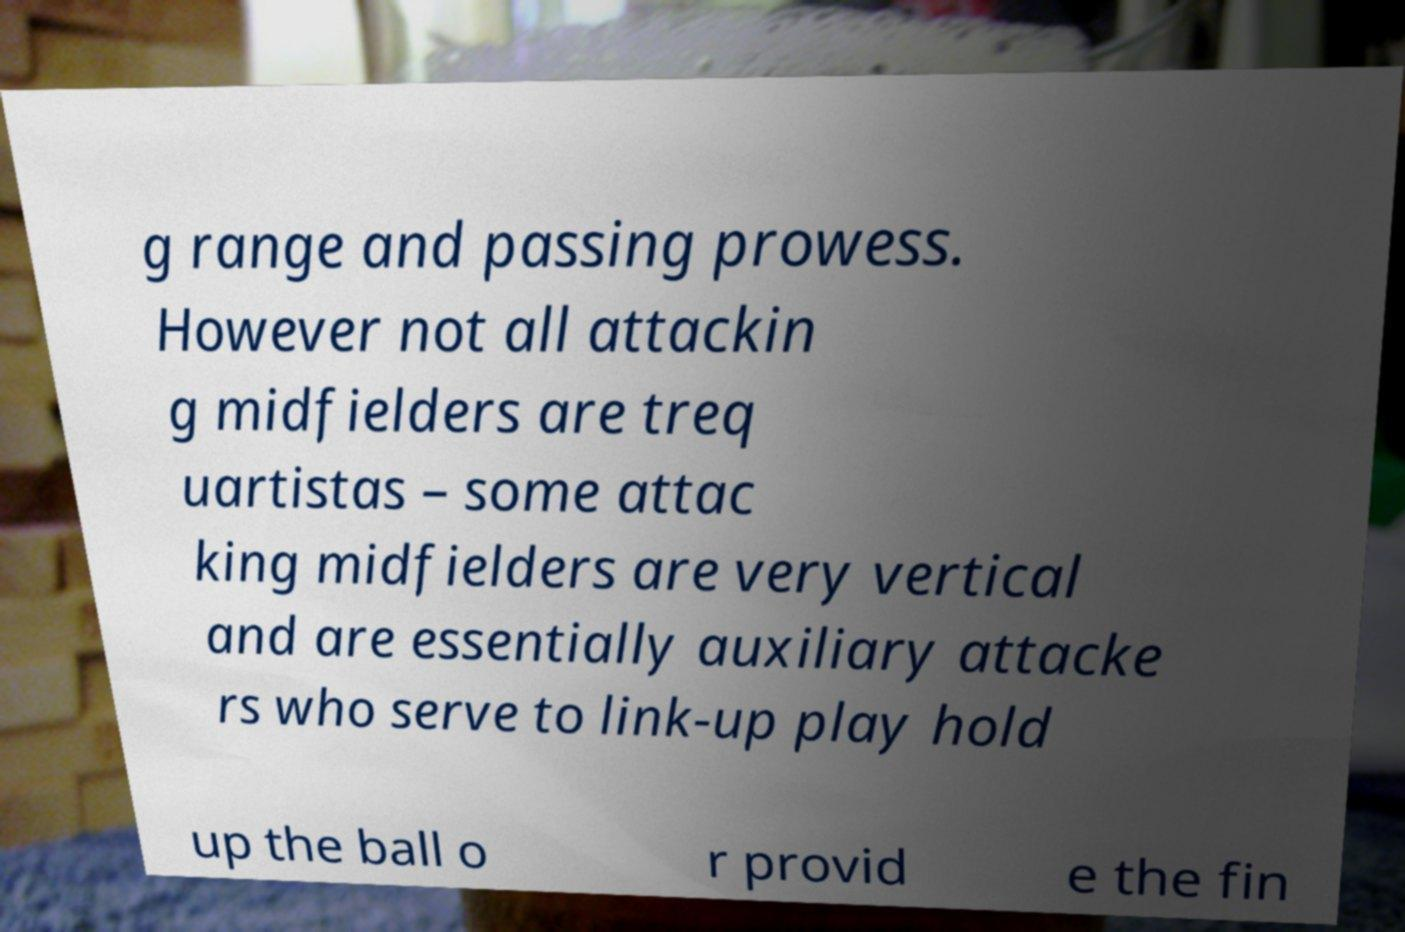Please identify and transcribe the text found in this image. g range and passing prowess. However not all attackin g midfielders are treq uartistas – some attac king midfielders are very vertical and are essentially auxiliary attacke rs who serve to link-up play hold up the ball o r provid e the fin 